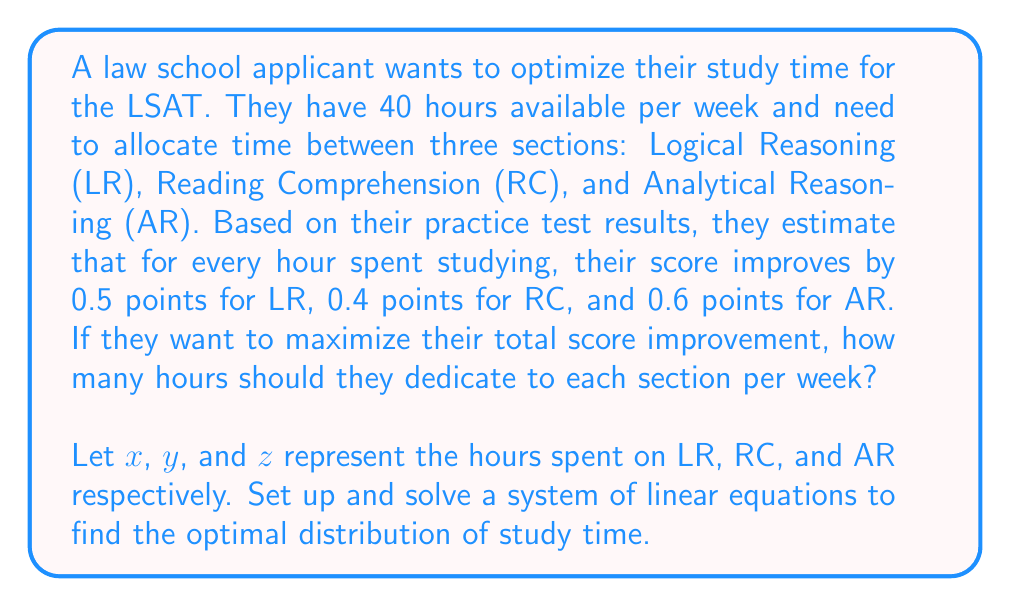Teach me how to tackle this problem. To solve this problem, we'll follow these steps:

1) First, let's set up our objective function. We want to maximize the total score improvement:

   $$ 0.5x + 0.4y + 0.6z = \text{Total Score Improvement} $$

2) We have a constraint on the total number of hours:

   $$ x + y + z = 40 $$

3) To maximize the objective function subject to this constraint, we need to allocate all our time to the section with the highest point improvement per hour, which is AR (0.6 points/hour).

4) Therefore, we should set:

   $$ z = 40 $$
   $$ x = 0 $$
   $$ y = 0 $$

5) Let's verify that this satisfies our constraint:

   $$ 0 + 0 + 40 = 40 $$

6) The total score improvement will be:

   $$ 0.5(0) + 0.4(0) + 0.6(40) = 24 \text{ points} $$

This distribution gives the maximum possible score improvement given the constraints.
Answer: LR: 0 hours, RC: 0 hours, AR: 40 hours 